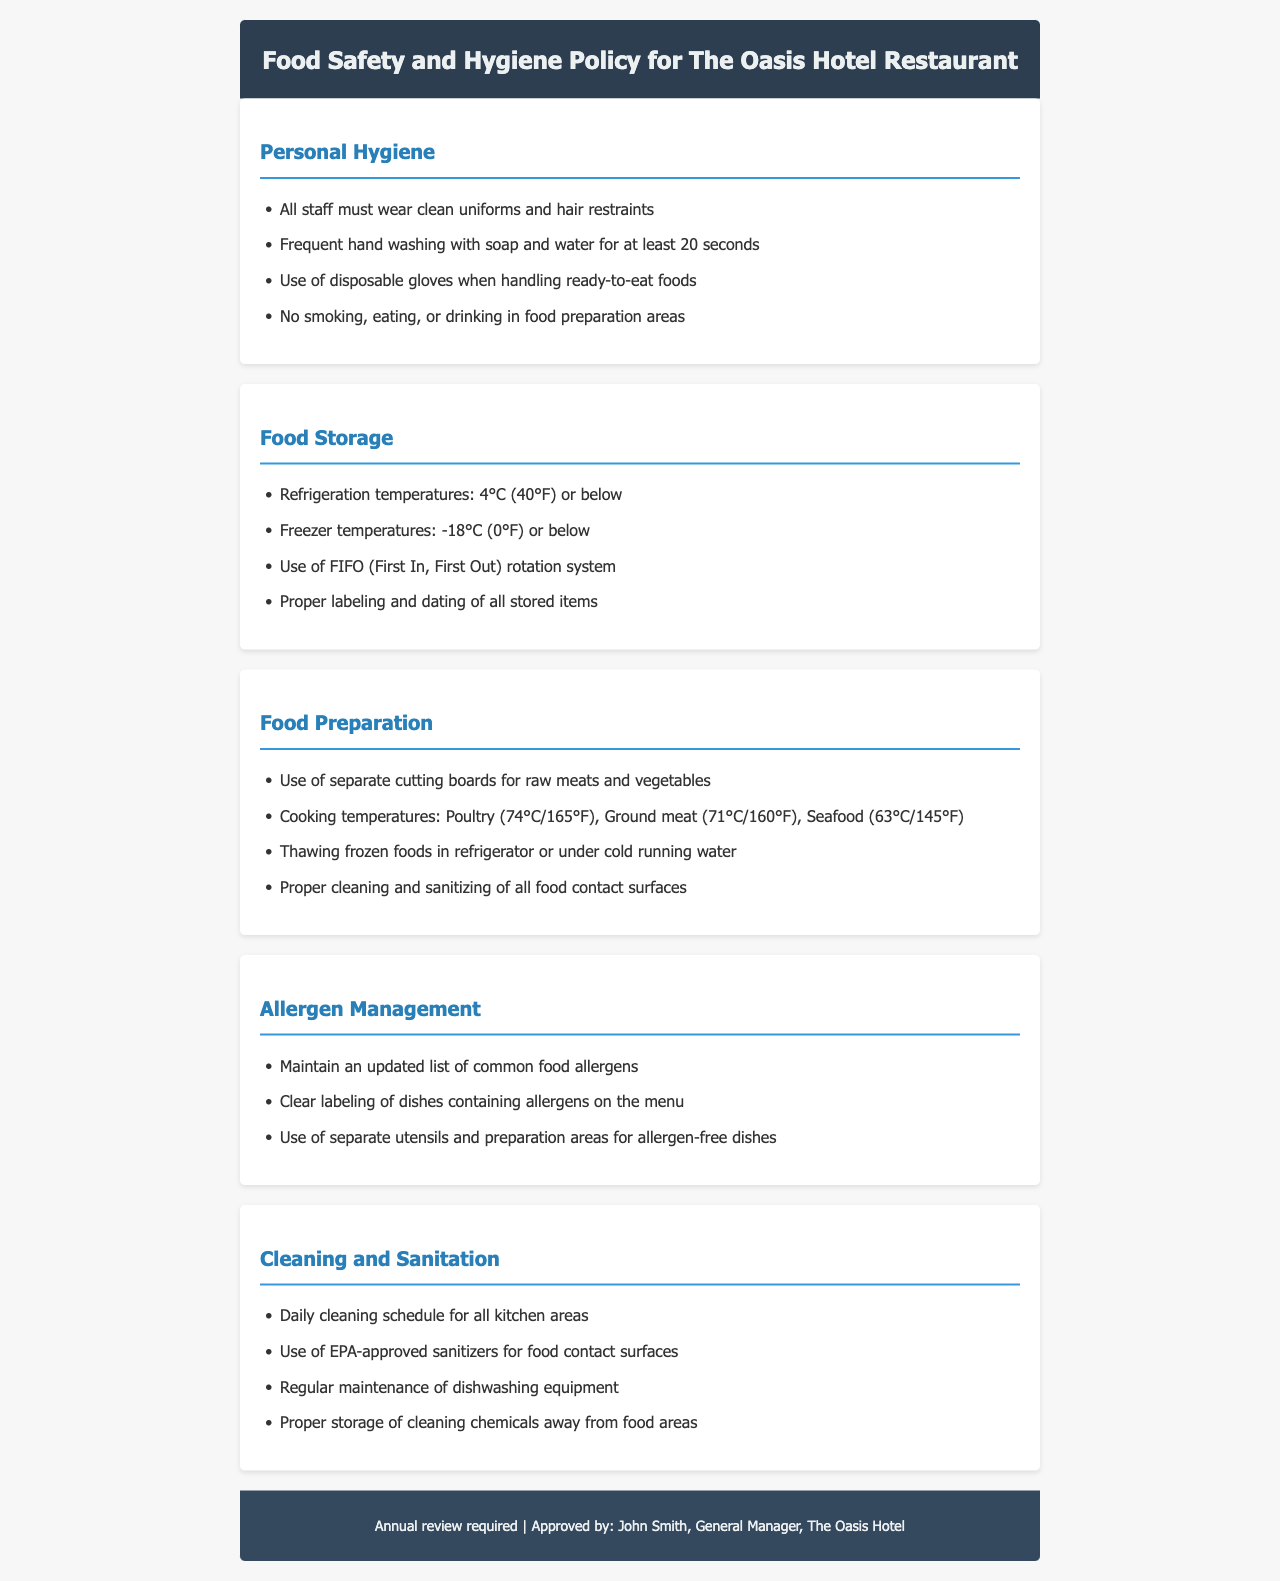What is the temperature limit for refrigeration? The document states that refrigeration temperatures should be 4°C (40°F) or below.
Answer: 4°C (40°F) What must all staff wear in the kitchen? According to the document, all staff must wear clean uniforms and hair restraints.
Answer: Clean uniforms and hair restraints What is the cooking temperature for poultry? The document specifies that poultry should be cooked to 74°C (165°F).
Answer: 74°C (165°F) Which rotation system should be used for food storage? The document recommends using the FIFO (First In, First Out) rotation system.
Answer: FIFO What should be used for thawing frozen foods? The document advises thawing frozen foods in the refrigerator or under cold running water.
Answer: Refrigerator or cold running water How often should kitchen areas be cleaned? The document mentions a daily cleaning schedule for all kitchen areas.
Answer: Daily What should be labeled clearly on the menu? The document states that dishes containing allergens should be clearly labeled on the menu.
Answer: Dishes containing allergens What type of sanitizers should be used on food contact surfaces? The document specifies the use of EPA-approved sanitizers for food contact surfaces.
Answer: EPA-approved sanitizers 